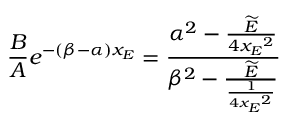<formula> <loc_0><loc_0><loc_500><loc_500>{ { \frac { B } { A } } e ^ { - ( \beta - \alpha ) x _ { E } } = { \frac { { \alpha } ^ { 2 } - { \frac { \widetilde { E } } { 4 { x _ { E } } ^ { 2 } } } } { { \beta } ^ { 2 } - { \frac { \widetilde { E } } { \frac { 1 } { 4 { x _ { E } } ^ { 2 } } } } } } }</formula> 